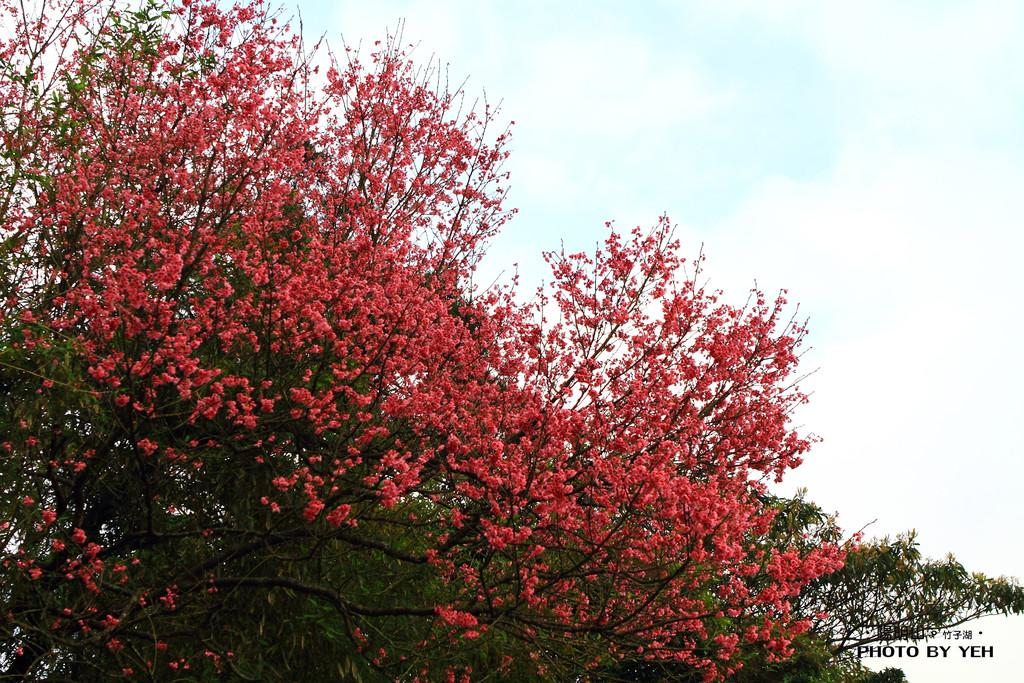What is the main subject in the center of the image? There is a tree in the center of the image. What can be seen in the background of the image? There are clouds and the sky visible in the background of the image. What type of jam is being spread on the underwear in the image? There is no jam or underwear present in the image; it only features a tree and clouds in the background. 